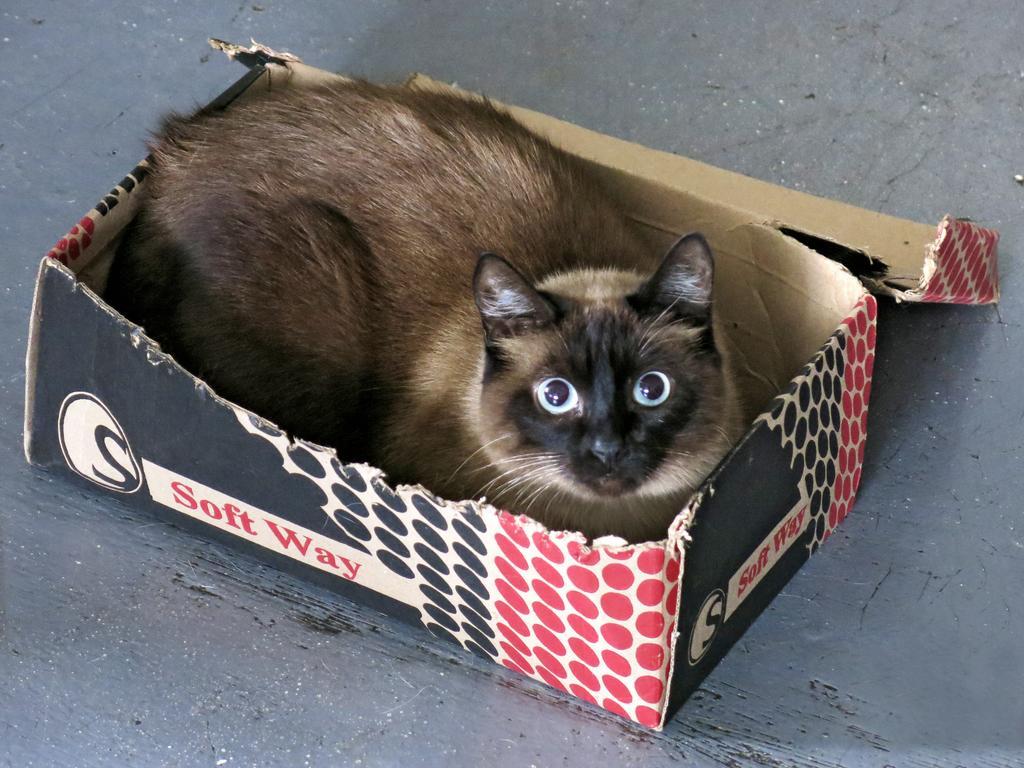Could you give a brief overview of what you see in this image? In the image we can see a box. In the box there is a cat. 